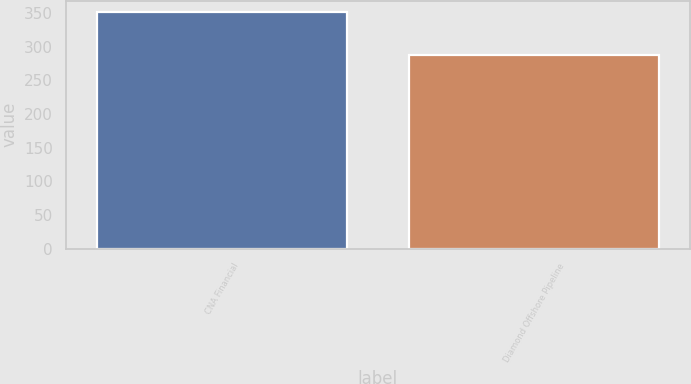Convert chart to OTSL. <chart><loc_0><loc_0><loc_500><loc_500><bar_chart><fcel>CNA Financial<fcel>Diamond Offshore Pipeline<nl><fcel>351<fcel>287<nl></chart> 